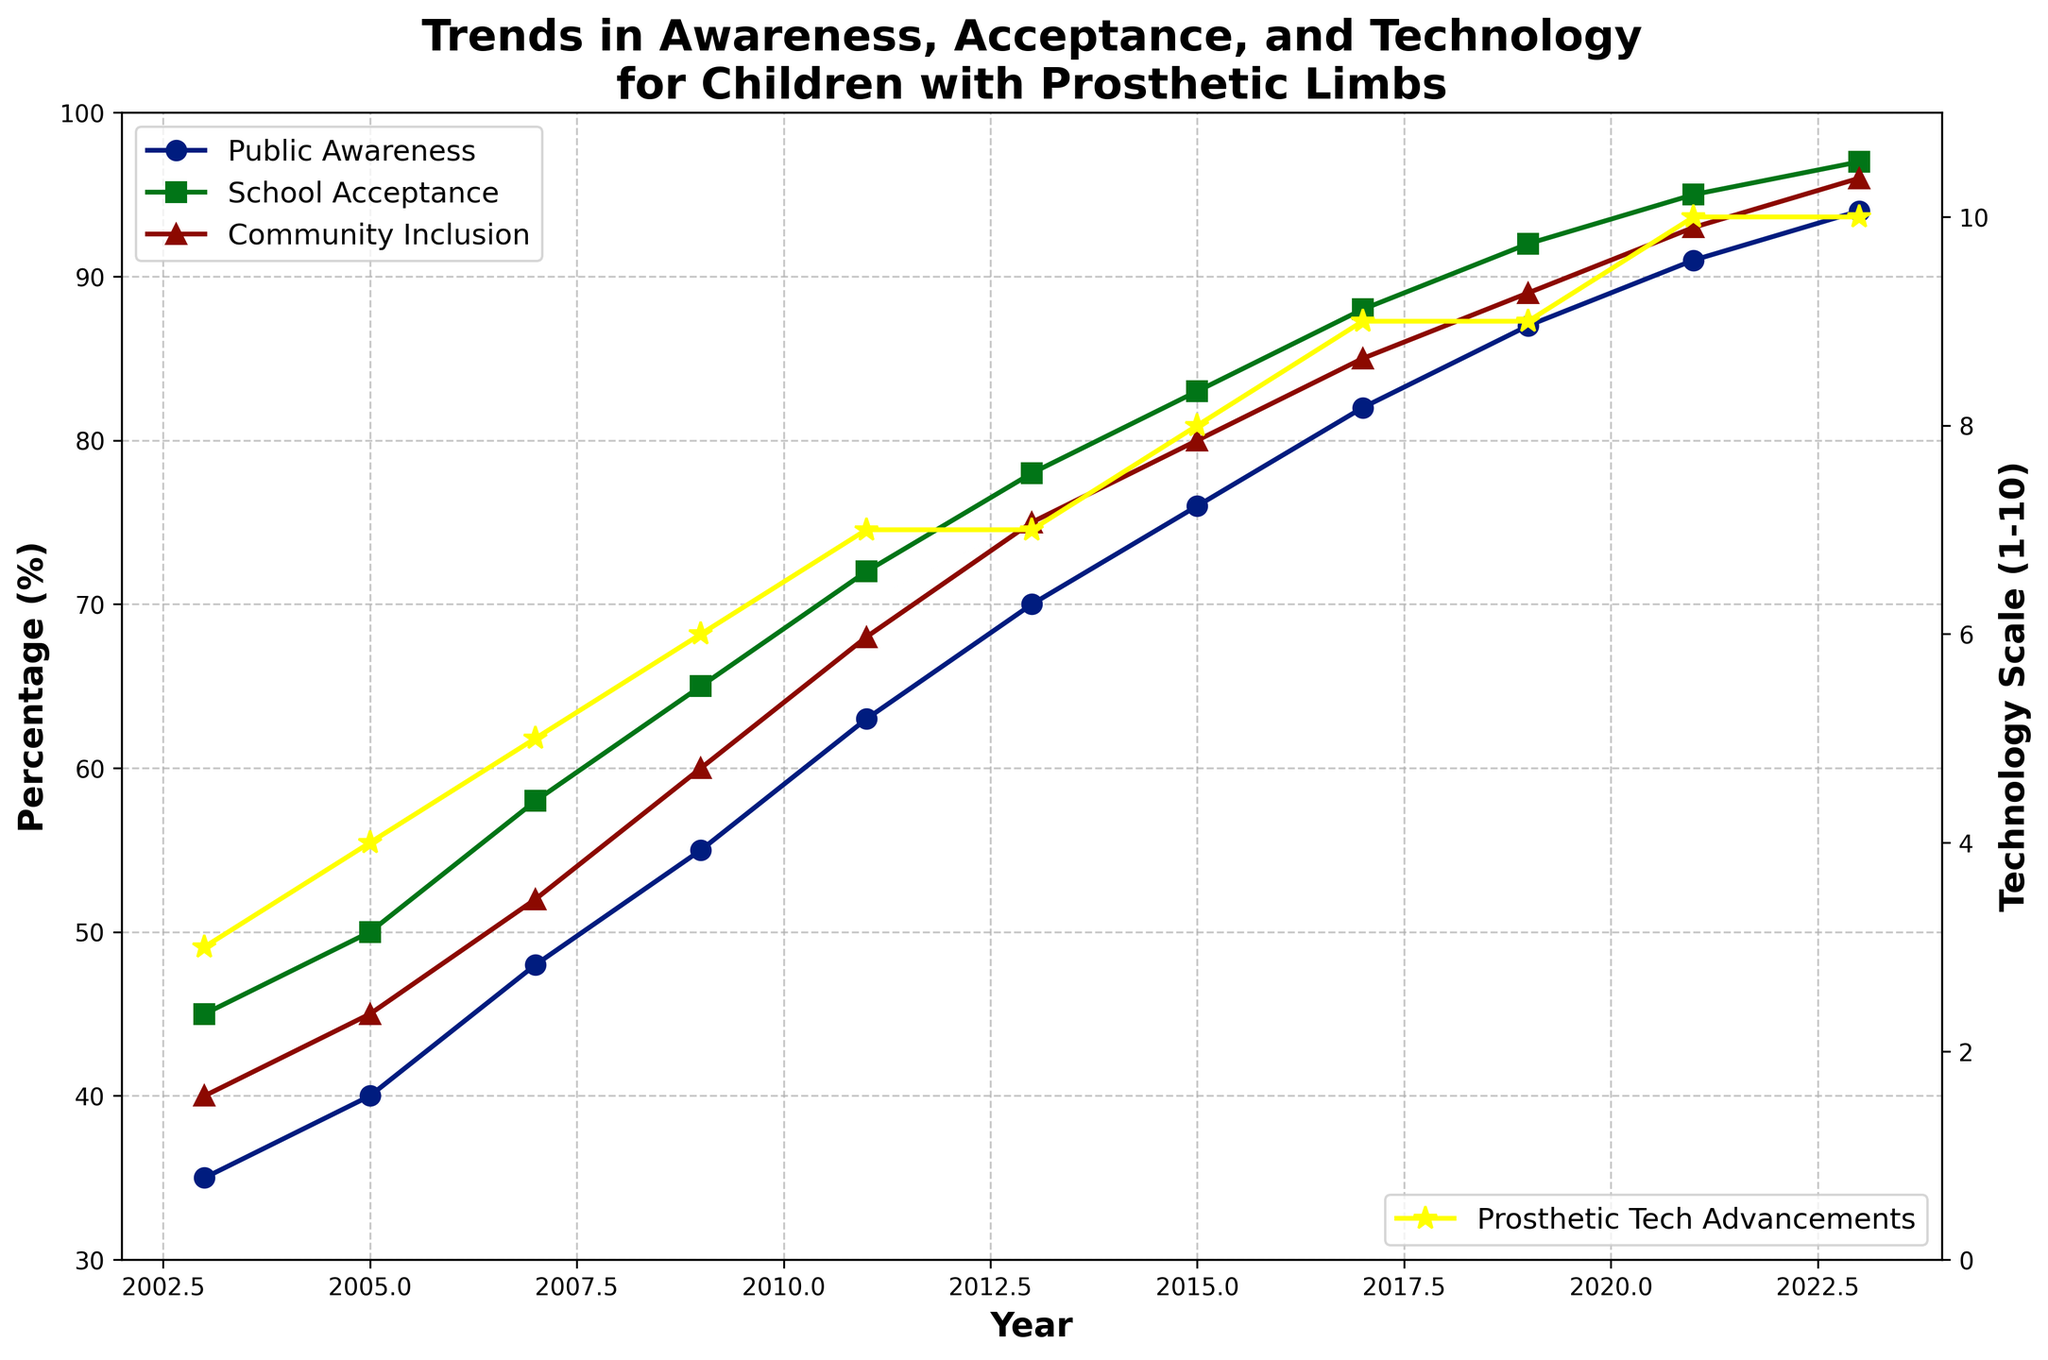What is the difference in Public Awareness percentage between 2003 and 2023? To find the difference in Public Awareness percentage between 2003 and 2023, subtract the percentage in 2003 (35%) from the percentage in 2023 (94%). The calculation is 94% - 35% = 59%.
Answer: 59% How does School Acceptance in 2009 compare to that in 2021? Compare the School Acceptance percentages in 2009 and 2021. In 2009, it was 65%, and in 2021, it was 95%. Since 95% is greater than 65%, School Acceptance significantly increased.
Answer: School Acceptance increased Which year saw the biggest increase in Community Inclusion percentage? To find the year with the biggest increase in Community Inclusion percentage, calculate the year-to-year differences: 2003-2005: 5%, 2005-2007: 7%, 2007-2009: 8%, 2009-2011: 8%, 2011-2013: 7%, 2013-2015: 5%, 2015-2017: 5%, 2017-2019: 4%, 2019-2021: 4%, 2021-2023: 3%. The largest increase happened from 2007 to 2009 with an 8% rise.
Answer: 2007-2009 What is the average Prosthetic Technology Advancement scale for the years 2003, 2005, and 2007? To calculate the average, sum the scales for 2003 (3), 2005 (4), and 2007 (5), resulting in 3 + 4 + 5 = 12, then divide by the number of data points (3), so 12 / 3 = 4.
Answer: 4 In which year did Public Awareness first surpass 80%? Scan the years on the x-axis and identify when Public Awareness first exceeded 80%. In 2017, Public Awareness was 82%, surpassing 80% for the first time.
Answer: 2017 Which measure (Public Awareness, School Acceptance, Community Inclusion) had the highest percentage in 2023? Compare the 2023 percentages for Public Awareness (94%), School Acceptance (97%), and Community Inclusion (96%). School Acceptance had the highest value at 97%.
Answer: School Acceptance What is the trend in Prosthetic Technology Advancements scale from 2003 to 2023? Observe the yellow line representing Prosthetic Technology Advancements from 2003 (scale 3) to 2023 (scale 10). The scale consistently increased over the years, reflecting continuous advancements.
Answer: Increasing trend How did the percentage of Public Awareness change from 2015 to 2019? Evaluate the change in percentage from 2015 (76%) to 2019 (87%). The change is 87% - 76% = 11%.
Answer: Increased by 11% Is there a visible correlation between Prosthetic Technology Advancements and Public Awareness from 2003 to 2023? Analyze the trends. Both Prosthetic Technology Advancements and Public Awareness show an upward trend. As technology advances, public awareness increases, indicating a positive correlation.
Answer: Yes 